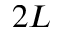<formula> <loc_0><loc_0><loc_500><loc_500>2 L</formula> 